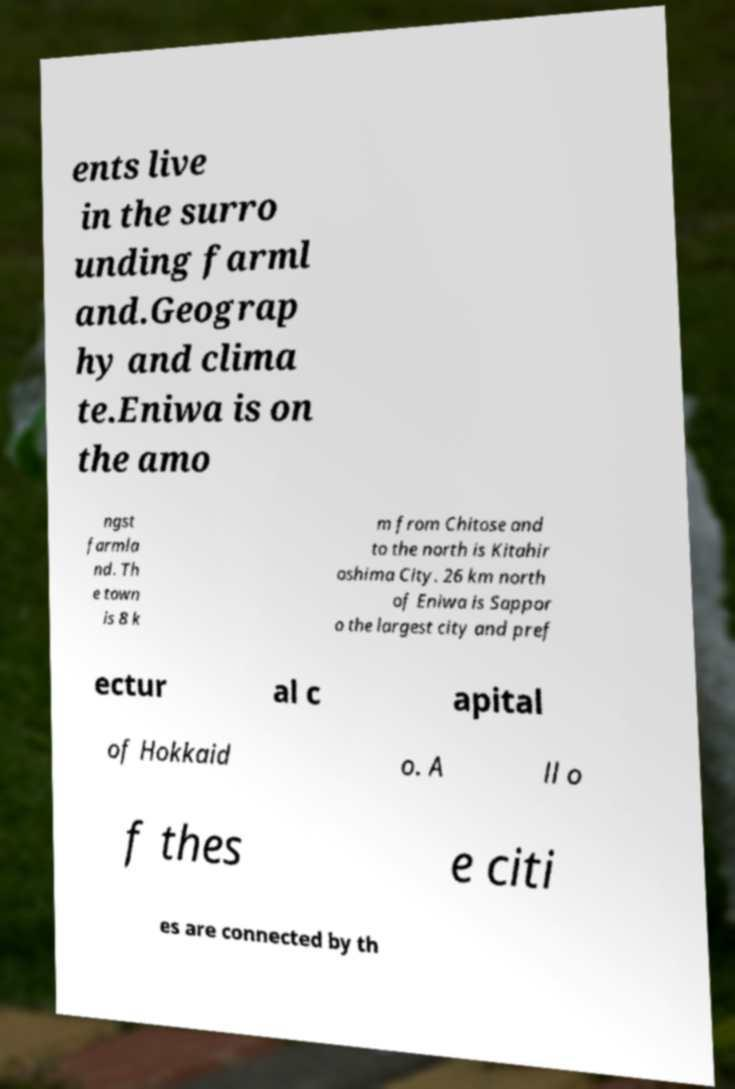For documentation purposes, I need the text within this image transcribed. Could you provide that? ents live in the surro unding farml and.Geograp hy and clima te.Eniwa is on the amo ngst farmla nd. Th e town is 8 k m from Chitose and to the north is Kitahir oshima City. 26 km north of Eniwa is Sappor o the largest city and pref ectur al c apital of Hokkaid o. A ll o f thes e citi es are connected by th 